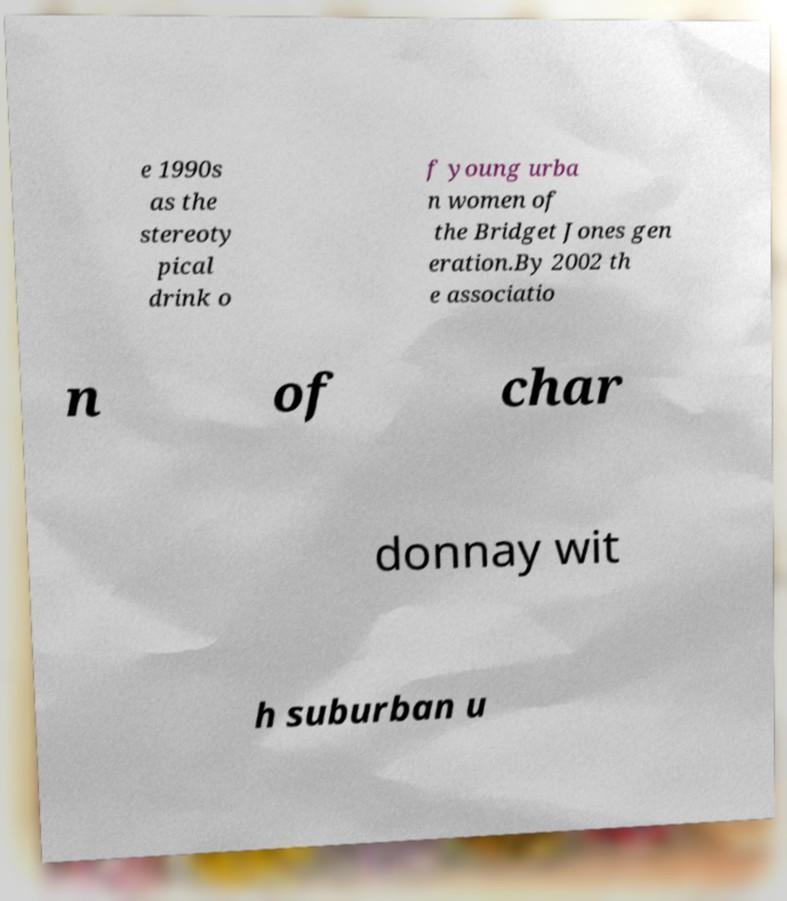Can you accurately transcribe the text from the provided image for me? e 1990s as the stereoty pical drink o f young urba n women of the Bridget Jones gen eration.By 2002 th e associatio n of char donnay wit h suburban u 